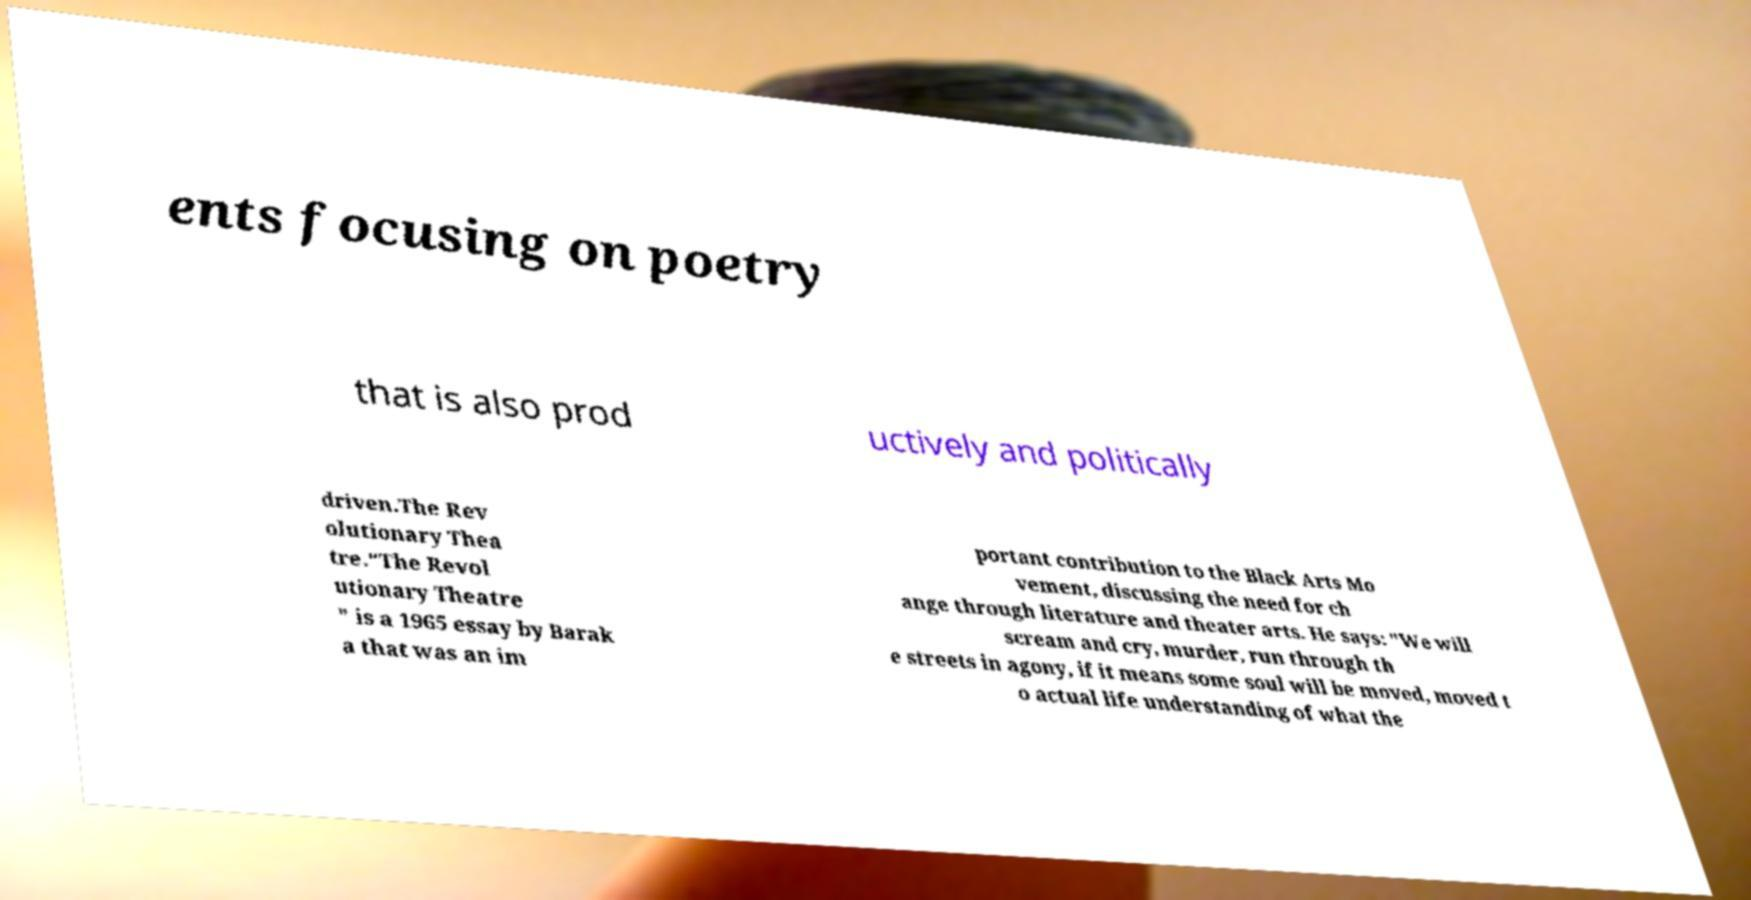There's text embedded in this image that I need extracted. Can you transcribe it verbatim? ents focusing on poetry that is also prod uctively and politically driven.The Rev olutionary Thea tre."The Revol utionary Theatre " is a 1965 essay by Barak a that was an im portant contribution to the Black Arts Mo vement, discussing the need for ch ange through literature and theater arts. He says: "We will scream and cry, murder, run through th e streets in agony, if it means some soul will be moved, moved t o actual life understanding of what the 